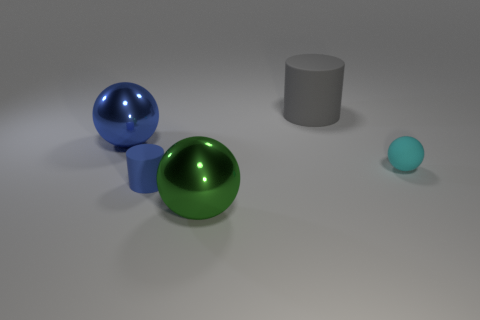Subtract all big spheres. How many spheres are left? 1 Add 3 large blue balls. How many objects exist? 8 Subtract all spheres. How many objects are left? 2 Add 3 gray blocks. How many gray blocks exist? 3 Subtract 0 red balls. How many objects are left? 5 Subtract all large cyan rubber cylinders. Subtract all metal spheres. How many objects are left? 3 Add 4 metal things. How many metal things are left? 6 